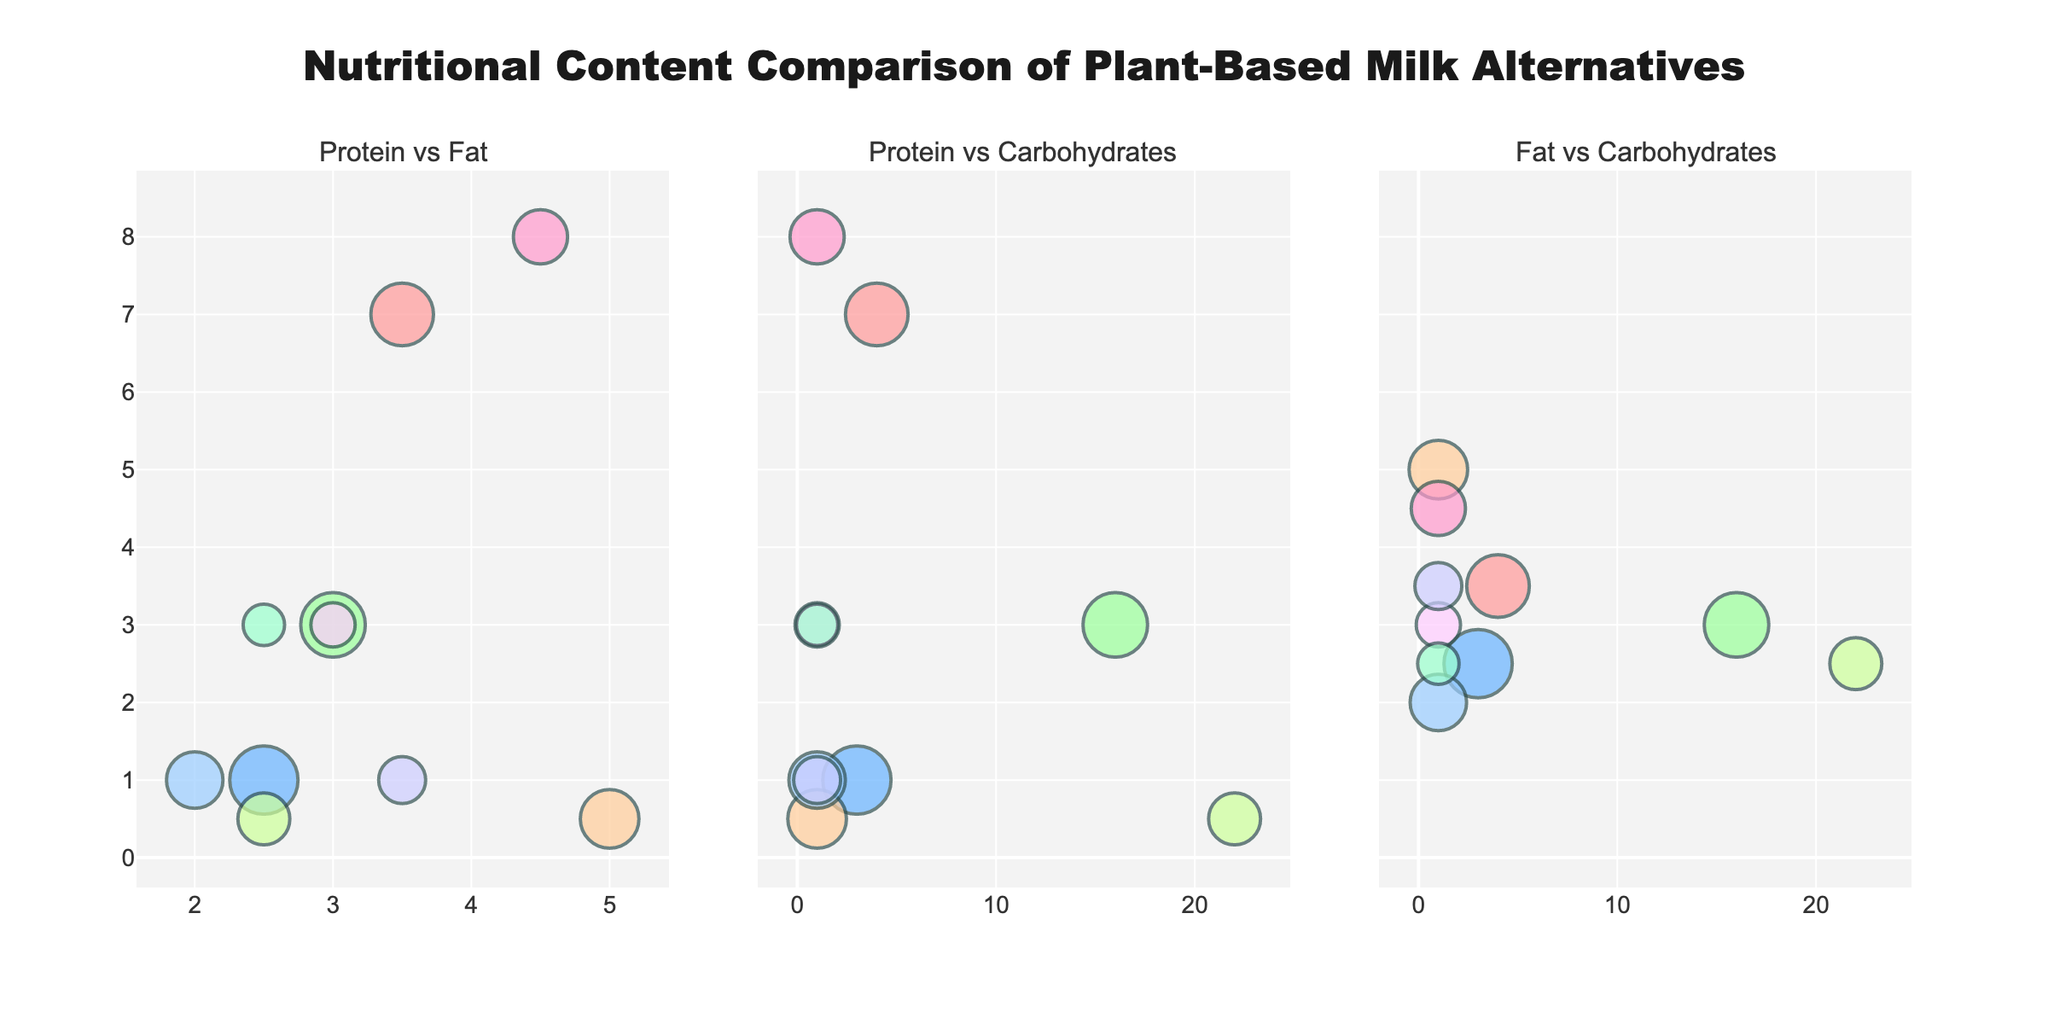What's the title of the figure? The title can be found at the top center of the figure. It states the main subject of the figure which is the nutritional content comparison of different plant-based milk alternatives.
Answer: Nutritional Content Comparison of Plant-Based Milk Alternatives What is the relationship between protein and fat for Soy milk? To find the relationship for Soy milk, locate the bubble representing Soy milk in the "Protein vs Fat" subplot. Check the coordinates for its position on the protein (y) and fat (x) axes.
Answer: 7 grams of protein, 3.5 grams of fat Which milk alternative has the highest carbohydrate content? Check the "Protein vs Carbohydrates" and "Fat vs Carbohydrates" subplots. Identify the milk alternative with the highest position along the carbohydrate (x) axis.
Answer: Rice milk What can be said about the popularity of Almond milk compared to Pea milk? Observe the size of the bubbles for Almond milk and Pea milk. The size of the bubbles indicates their relative popularity. Almond milk has a larger bubble compared to Pea milk in all subplots.
Answer: Almond milk is more popular than Pea milk Which subplot contains Rice milk having the highest value on the y-axis? To answer, locate Rice milk in all subplots and identify where it has the highest y-axis value. This is in the "Fat vs Carbohydrates" subplot.
Answer: Fat vs Carbohydrates How many plant-based milks have a protein content of 3 grams? Locate the y-axis which represents the protein content in both "Protein vs Fat" and "Protein vs Carbohydrates" subplots. Count the bubbles at the 3 grams protein mark.
Answer: 3 (Oat milk, Hemp milk, Flax milk) Based on the comparison, which milk type is likely the most balanced in protein and fat content? To determine, look for bubbles that are approximately equidistant from the origin in the "Protein vs Fat" subplot. Identify the one with similar values.
Answer: Pea milk Which milk type has the highest fat content but low protein content? Locate the milk type with the highest x value but low y value in the "Protein vs Fat" subplot. The highest on the fat axis with low protein.
Answer: Coconut milk If we consider both carbohydrates and popularity, which milk is the least popular with the highest carbohydrate content? Check the "Protein vs Carbohydrates" and "Fat vs Carbohydrates" subplots for the highest x value and then check the size of the bubble for the least popular milk.
Answer: Rice milk 